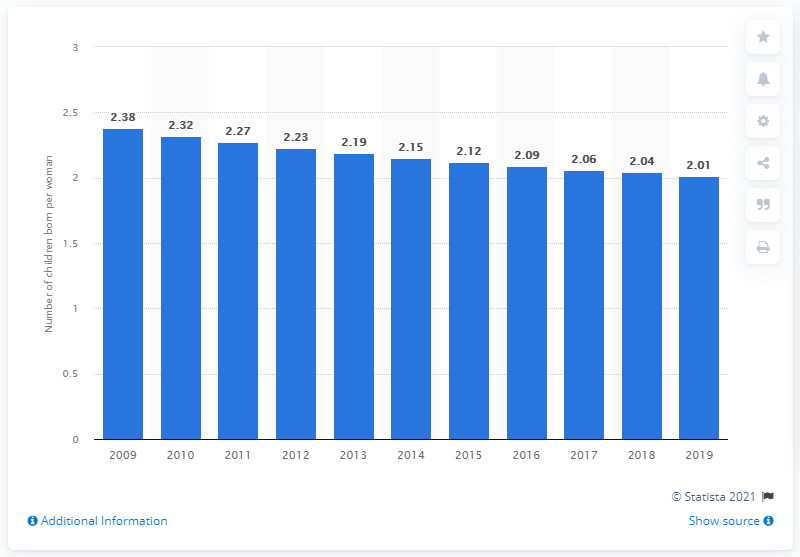Identify some key points in this picture. The fertility rate in Bangladesh in 2019 was 2.01. 